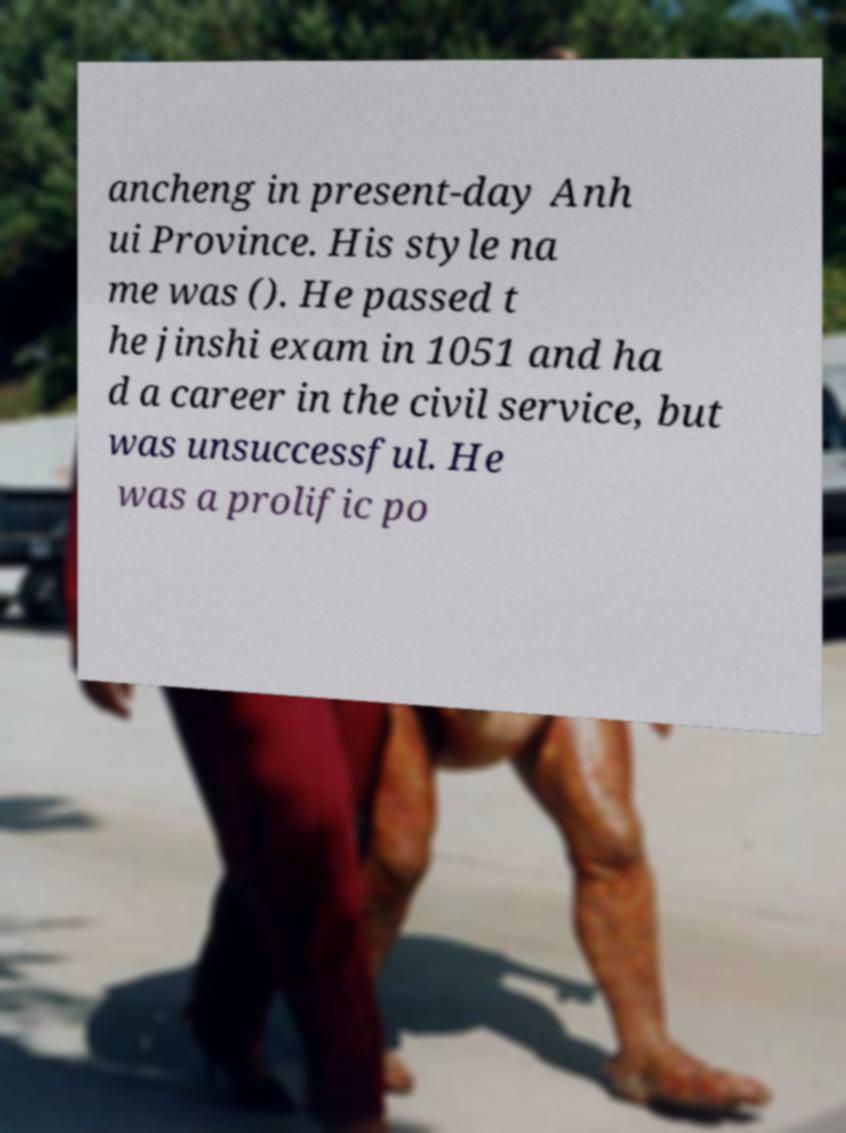Could you assist in decoding the text presented in this image and type it out clearly? ancheng in present-day Anh ui Province. His style na me was (). He passed t he jinshi exam in 1051 and ha d a career in the civil service, but was unsuccessful. He was a prolific po 